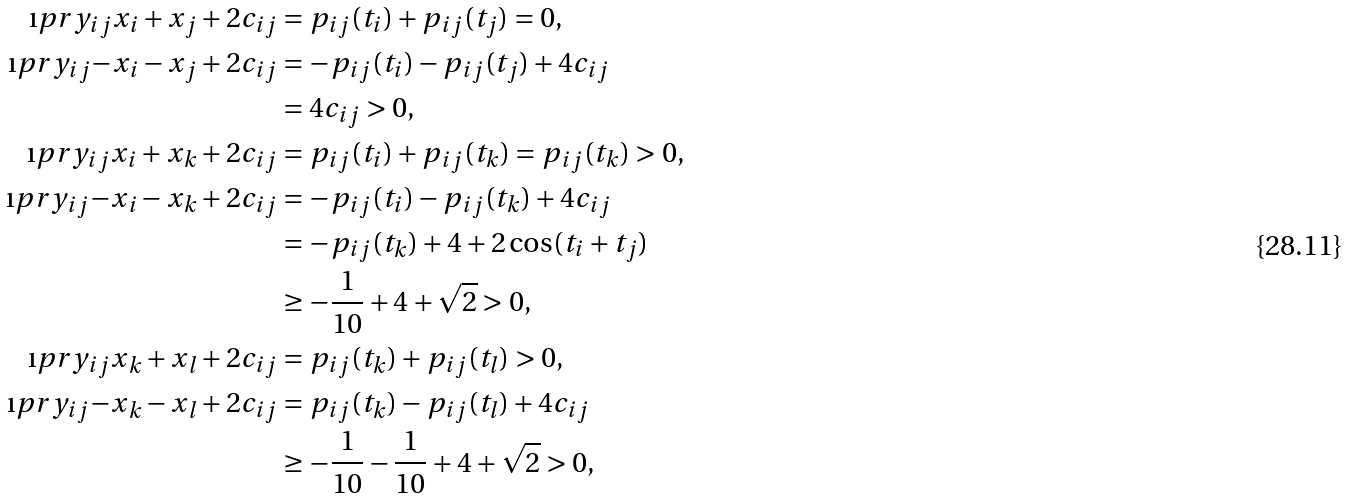<formula> <loc_0><loc_0><loc_500><loc_500>\i p r { y _ { i j } } { x _ { i } + x _ { j } } + 2 c _ { i j } & = p _ { i j } ( t _ { i } ) + p _ { i j } ( t _ { j } ) = 0 , \\ \i p r { y _ { i j } } { - x _ { i } - x _ { j } } + 2 c _ { i j } & = - p _ { i j } ( t _ { i } ) - p _ { i j } ( t _ { j } ) + 4 c _ { i j } \\ & = 4 c _ { i j } > 0 , \\ \i p r { y _ { i j } } { x _ { i } + x _ { k } } + 2 c _ { i j } & = p _ { i j } ( t _ { i } ) + p _ { i j } ( t _ { k } ) = p _ { i j } ( t _ { k } ) > 0 , \\ \i p r { y _ { i j } } { - x _ { i } - x _ { k } } + 2 c _ { i j } & = - p _ { i j } ( t _ { i } ) - p _ { i j } ( t _ { k } ) + 4 c _ { i j } \\ & = - p _ { i j } ( t _ { k } ) + 4 + 2 \cos ( t _ { i } + t _ { j } ) \\ & \geq - \frac { 1 } { 1 0 } + 4 + \sqrt { 2 } > 0 , \\ \i p r { y _ { i j } } { x _ { k } + x _ { l } } + 2 c _ { i j } & = p _ { i j } ( t _ { k } ) + p _ { i j } ( t _ { l } ) > 0 , \\ \i p r { y _ { i j } } { - x _ { k } - x _ { l } } + 2 c _ { i j } & = p _ { i j } ( t _ { k } ) - p _ { i j } ( t _ { l } ) + 4 c _ { i j } \\ & \geq - \frac { 1 } { 1 0 } - \frac { 1 } { 1 0 } + 4 + \sqrt { 2 } > 0 ,</formula> 